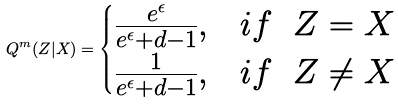<formula> <loc_0><loc_0><loc_500><loc_500>Q ^ { m } ( Z | X ) = \begin{cases} \frac { e ^ { \epsilon } } { e ^ { \epsilon } + d - 1 } , & i f \ \ Z = X \\ \frac { 1 } { e ^ { \epsilon } + d - 1 } , & i f \ \ Z \neq X \\ \end{cases}</formula> 